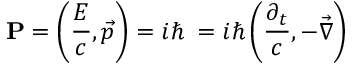Convert formula to latex. <formula><loc_0><loc_0><loc_500><loc_500>P = \left ( { \frac { E } { c } } , { \vec { p } } \right ) = i \hbar { \partial } = i \hbar { \left } ( { \frac { \partial _ { t } } { c } } , - { \vec { \nabla } } \right )</formula> 